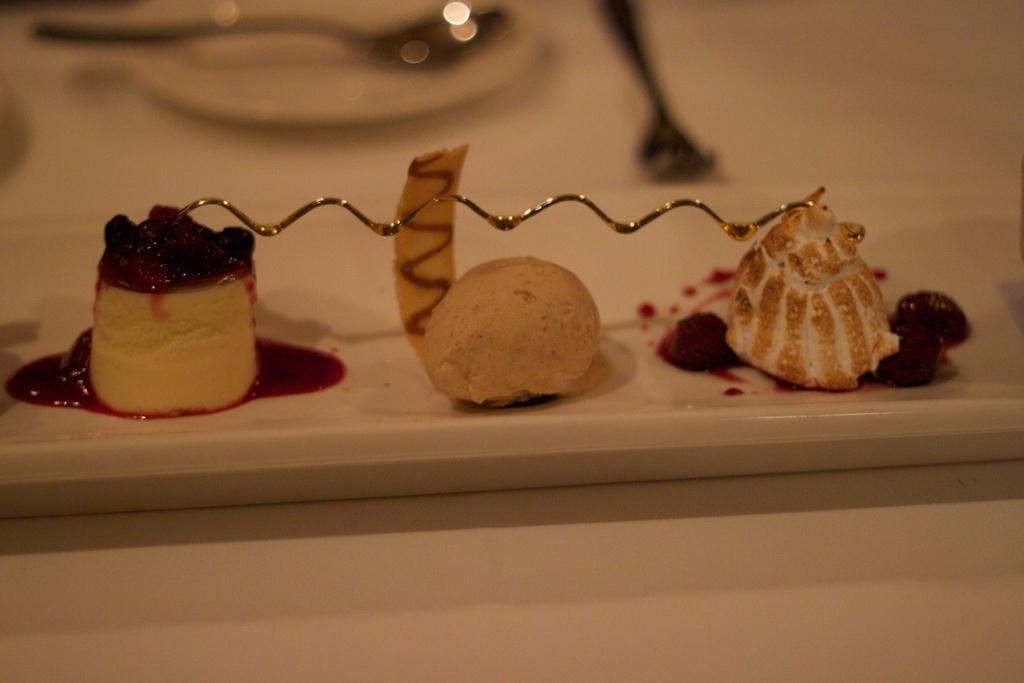What is the main subject of the image? The main subject of the image is food items in the center. Can you describe the setting of the image? The image appears to be set on a table. What other items can be seen in the background of the image? There is a plate and spoons in the background of the image. What type of attraction is present in the image? There is no attraction present in the image; it features food items, a plate, and spoons on a table. How does the tongue interact with the food items in the image? There is no tongue visible in the image, so it is not possible to determine how it might interact with the food items. 